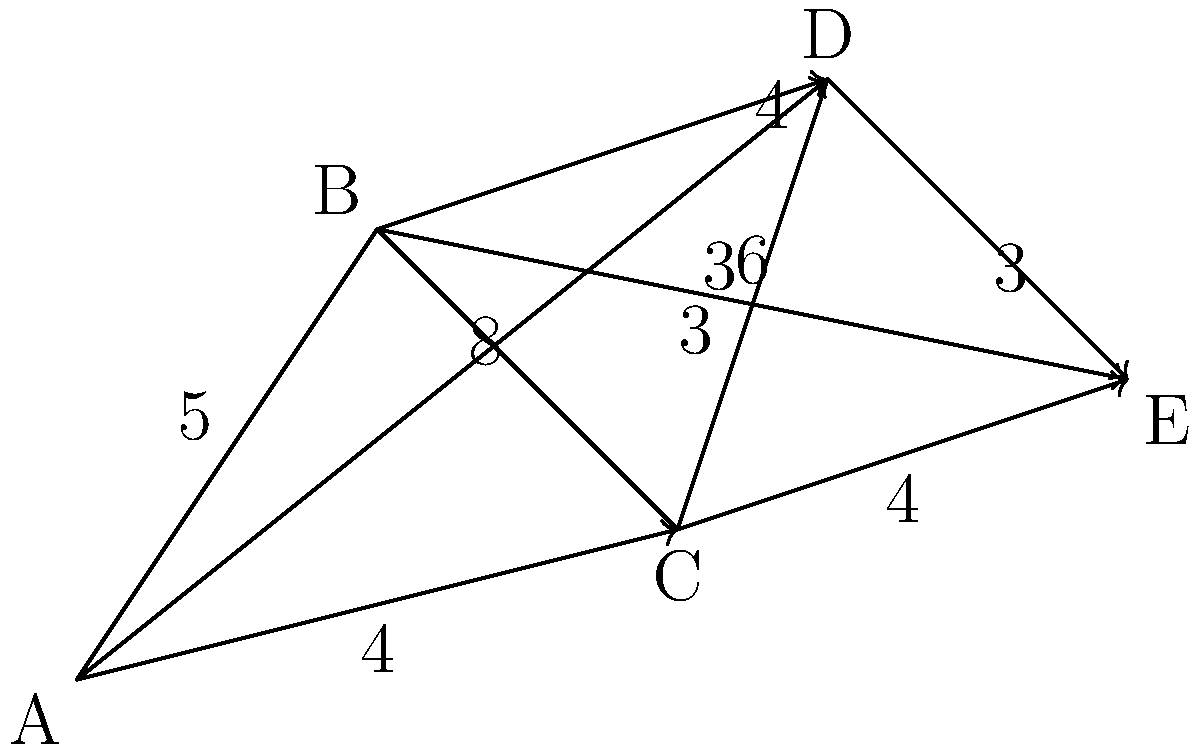As the administrative officer responsible for logistics, you need to determine the most efficient route for transporting delegates from venue A to venue E. The diagram shows the distances (in kilometers) between different venues. What is the shortest possible distance to travel from A to E? To find the shortest path from A to E, we need to consider all possible routes and calculate their total distances. Let's break it down step-by-step:

1. Possible routes:
   a) A → B → E
   b) A → C → E
   c) A → D → E
   d) A → B → C → E
   e) A → B → D → E
   f) A → C → D → E

2. Calculate the distances for each route:
   a) A → B → E = 5 + 6 = 11 km
   b) A → C → E = 4 + 4 = 8 km
   c) A → D → E = 8 + 3 = 11 km
   d) A → B → C → E = 5 + 3 + 4 = 12 km
   e) A → B → D → E = 5 + 4 + 3 = 12 km
   f) A → C → D → E = 4 + 3 + 3 = 10 km

3. Compare the total distances:
   The shortest route is A → C → E, with a total distance of 8 km.

4. Verify that no other combination of intermediate stops can produce a shorter route.

Therefore, the most efficient route for transporting delegates from venue A to venue E is through venue C, covering a total distance of 8 km.
Answer: 8 km 